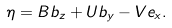Convert formula to latex. <formula><loc_0><loc_0><loc_500><loc_500>\eta = B b _ { z } + U b _ { y } - V e _ { x } .</formula> 